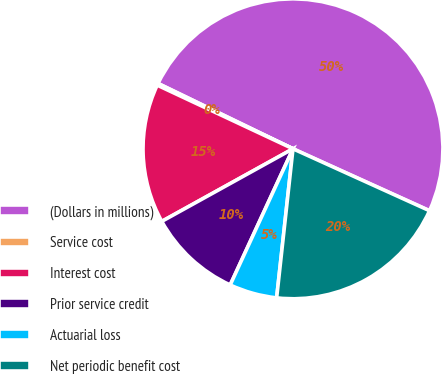Convert chart to OTSL. <chart><loc_0><loc_0><loc_500><loc_500><pie_chart><fcel>(Dollars in millions)<fcel>Service cost<fcel>Interest cost<fcel>Prior service credit<fcel>Actuarial loss<fcel>Net periodic benefit cost<nl><fcel>49.6%<fcel>0.2%<fcel>15.02%<fcel>10.08%<fcel>5.14%<fcel>19.96%<nl></chart> 